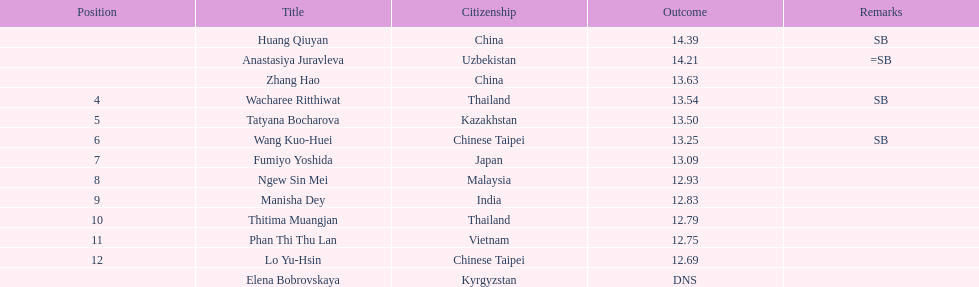How many participants were from thailand? 2. 